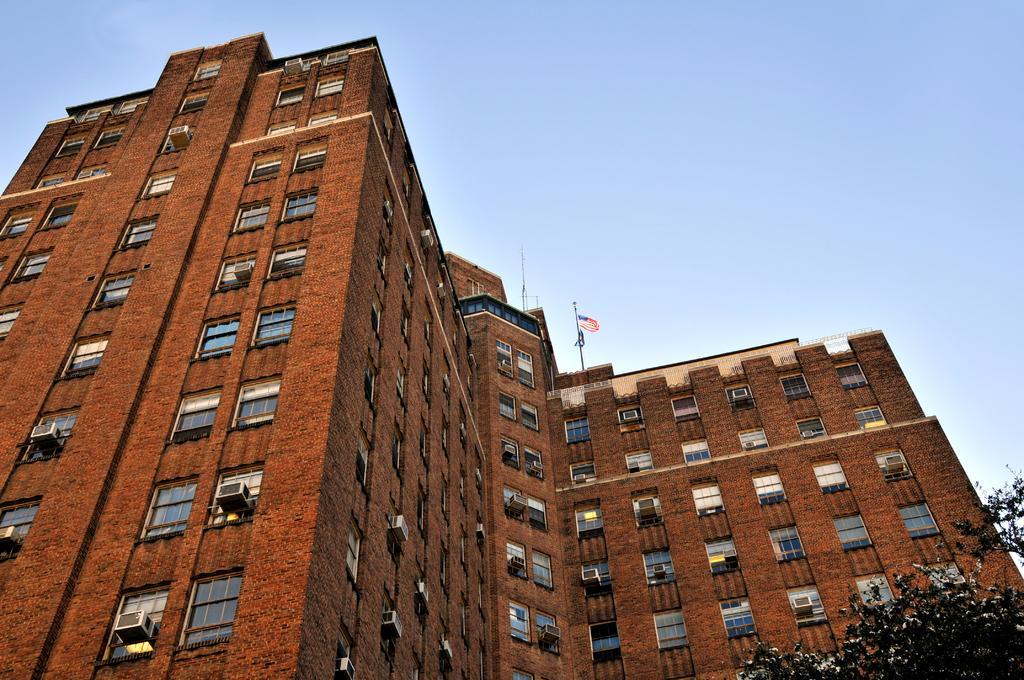How would you summarize this image in a sentence or two? In this picture there is a building. At the top of the building we can see the flag and pole. On the building we can see window AC near to the window and window cloth. In the bottom right corner there is a tree. At the top we can see a sky. 